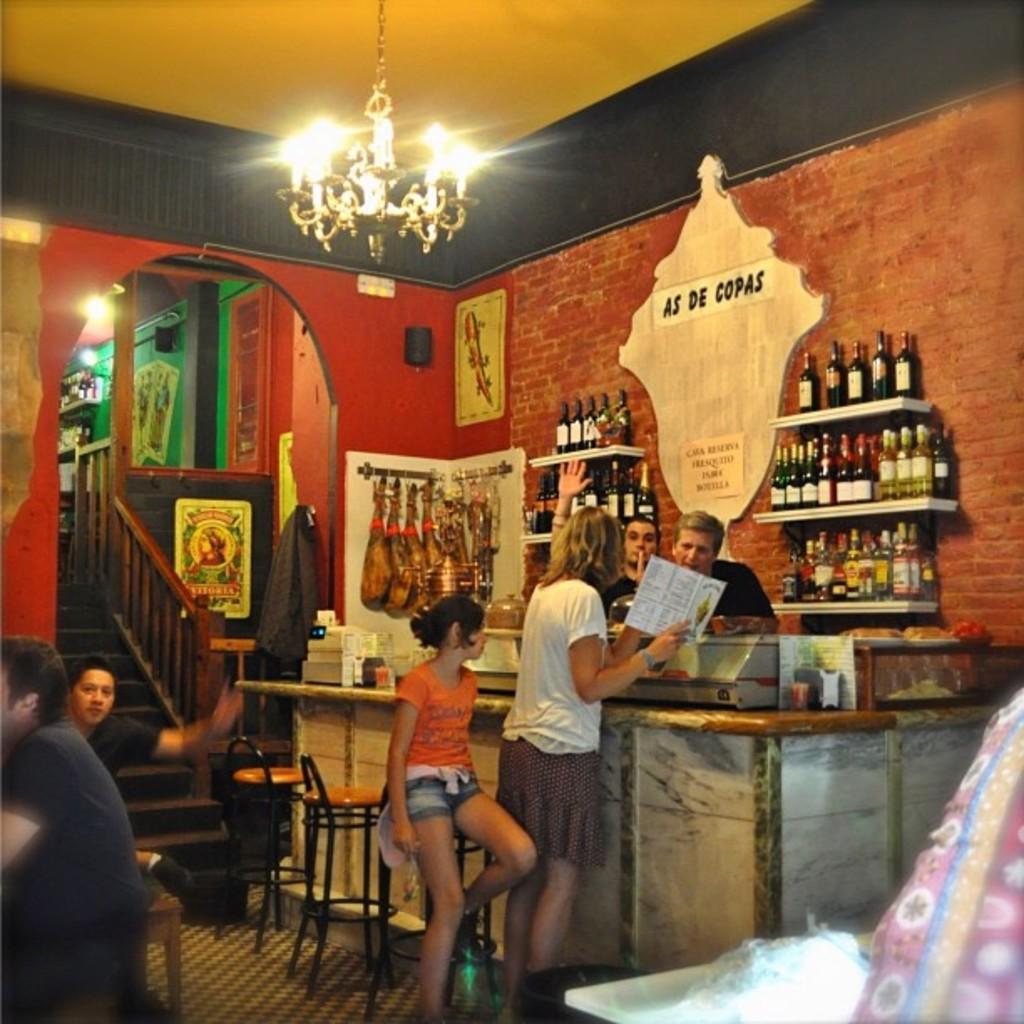Could you give a brief overview of what you see in this image? This is a picture from a bar. In the left side of the picture there are two people seated. on the top left there is staircase and a door, wall and another room. on the center of the picture there are racks and a desk, in the racks there are wine bottles. In the center of the picture there are four people, there are chairs, bags, jacket. On the right foreground there is a table and a person. 